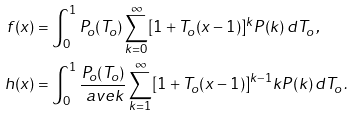<formula> <loc_0><loc_0><loc_500><loc_500>f ( x ) & = \int _ { 0 } ^ { 1 } P _ { o } ( T _ { o } ) \sum _ { k = 0 } ^ { \infty } [ 1 + T _ { o } ( x - 1 ) ] ^ { k } P ( k ) \, d T _ { o } \, , \\ h ( x ) & = \int _ { 0 } ^ { 1 } \frac { P _ { o } ( T _ { o } ) } { \ a v e { k } } \sum _ { k = 1 } ^ { \infty } [ 1 + T _ { o } ( x - 1 ) ] ^ { k - 1 } k P ( k ) \, d T _ { o } \, . \,</formula> 